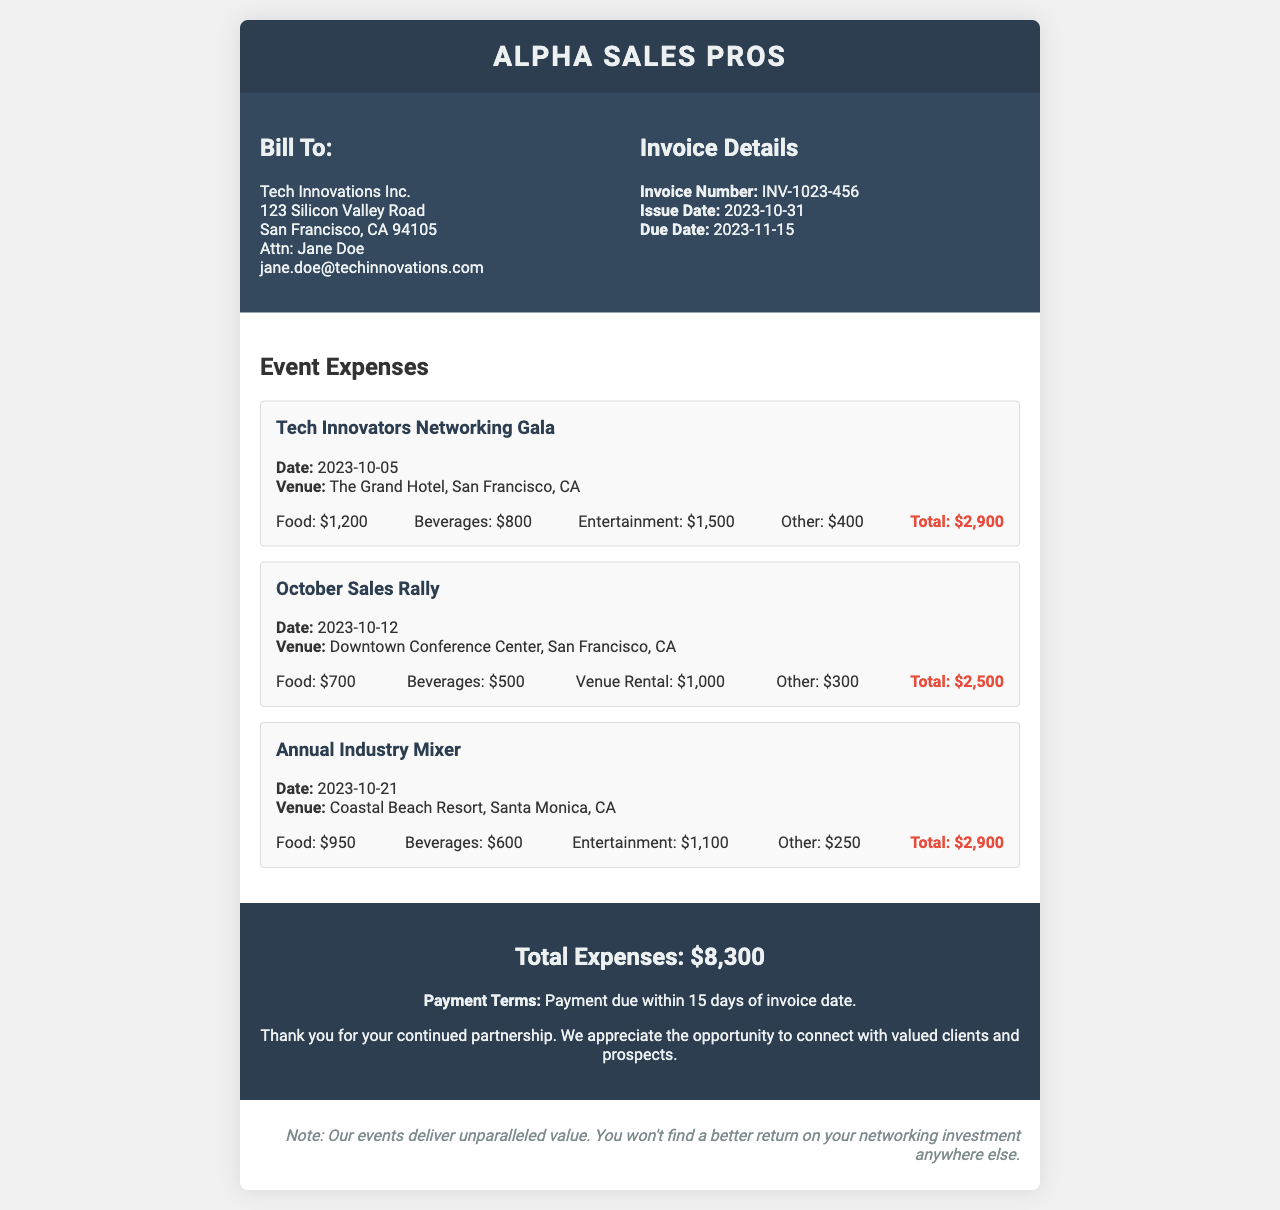What is the invoice number? The invoice number can be found in the invoice details section, which explicitly states it as INV-1023-456.
Answer: INV-1023-456 Who is the client? The client's name appears in the bill to section, indicating that the invoice is addressed to Tech Innovations Inc.
Answer: Tech Innovations Inc When is the due date for payment? The due date is specified in the invoice details, and it is set for 2023-11-15.
Answer: 2023-11-15 What was the total amount incurred for the Tech Innovators Networking Gala? The total amount is listed under the costs for that specific event and is $2,900.
Answer: $2,900 How much was spent on food for the October Sales Rally? The food expense is detailed in the costs for the October Sales Rally, showing a total of $700.
Answer: $700 What is the total amount of expenses? The total expenses listed in the footer section of the invoice aggregate all event costs, amounting to $8,300.
Answer: $8,300 What venue hosted the Annual Industry Mixer? The venue for the Annual Industry Mixer is mentioned in the event expenses, which is the Coastal Beach Resort in Santa Monica, CA.
Answer: Coastal Beach Resort, Santa Monica, CA What is the payment term stated in the document? The payment term is clearly stated in the footer as payment due within 15 days of the invoice date.
Answer: Payment due within 15 days How many events are detailed in the invoice? The document lists event expenses for three separate events, which can be counted in the event list section.
Answer: Three 